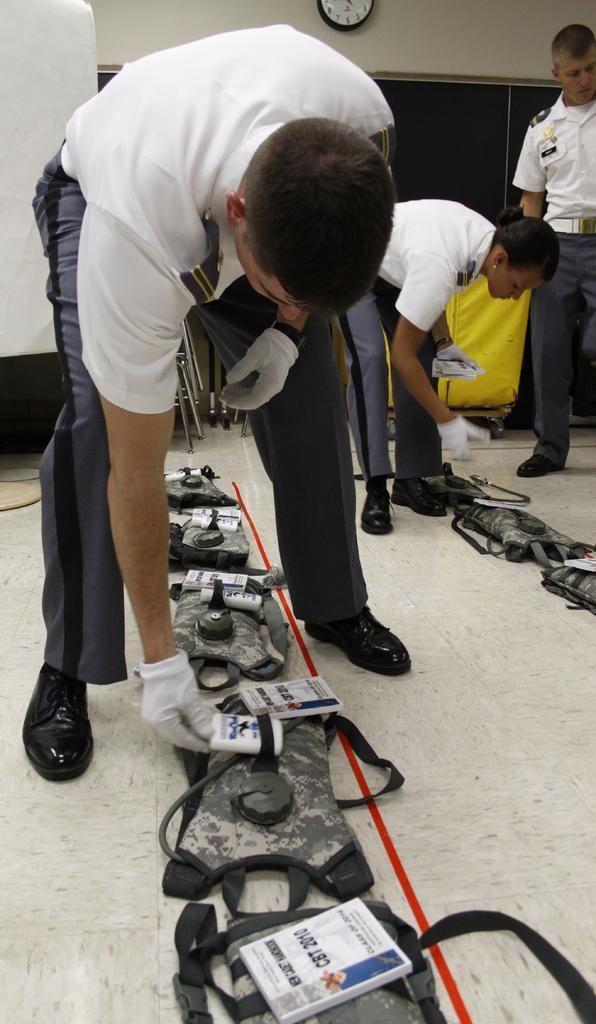Describe this image in one or two sentences. In this image we can see a few people, there are some life jackets on the floor, there is a box on the trolley, also we can see the windows, the wall clock on the wall, and some cards on the life jackets with some text on it. 